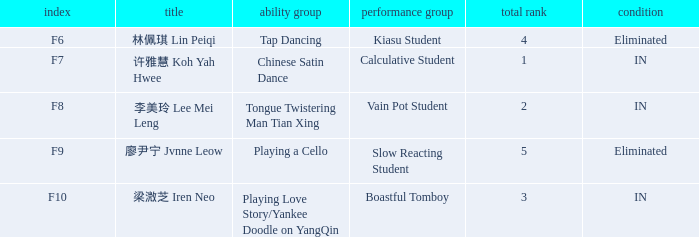What's the performance part of 林佩琪 lin peiqi's activities that are removed? Kiasu Student. 